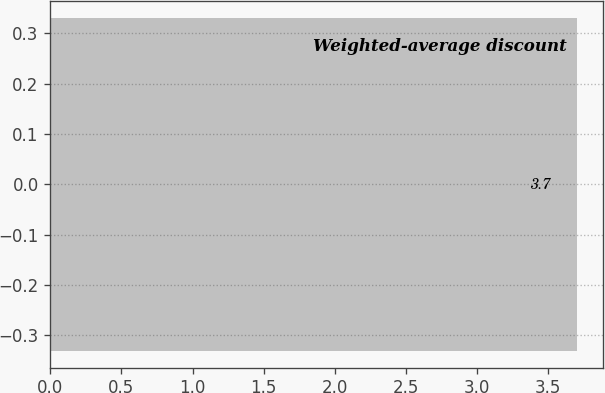<chart> <loc_0><loc_0><loc_500><loc_500><bar_chart><fcel>Weighted-average discount<nl><fcel>3.7<nl></chart> 